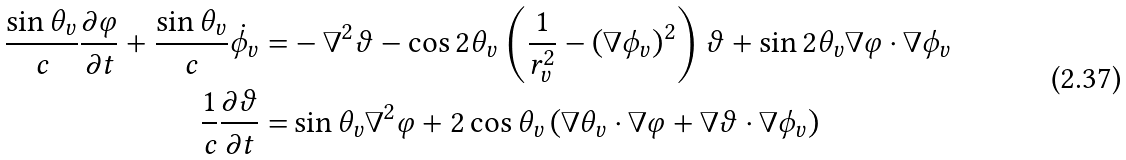<formula> <loc_0><loc_0><loc_500><loc_500>\frac { \sin \theta _ { v } } { c } \frac { \partial \varphi } { \partial t } + \frac { \sin \theta _ { v } } { c } \dot { \phi } _ { v } = & - \nabla ^ { 2 } \vartheta - \cos 2 \theta _ { v } \left ( \frac { 1 } { r _ { v } ^ { 2 } } - \left ( \nabla \phi _ { v } \right ) ^ { 2 } \right ) \vartheta + \sin 2 \theta _ { v } \nabla \varphi \cdot \nabla \phi _ { v } \\ \frac { 1 } { c } \frac { \partial \vartheta } { \partial t } = & \sin \theta _ { v } \nabla ^ { 2 } \varphi + 2 \cos \theta _ { v } \left ( \nabla \theta _ { v } \cdot \nabla \varphi + \nabla \vartheta \cdot \nabla \phi _ { v } \right )</formula> 